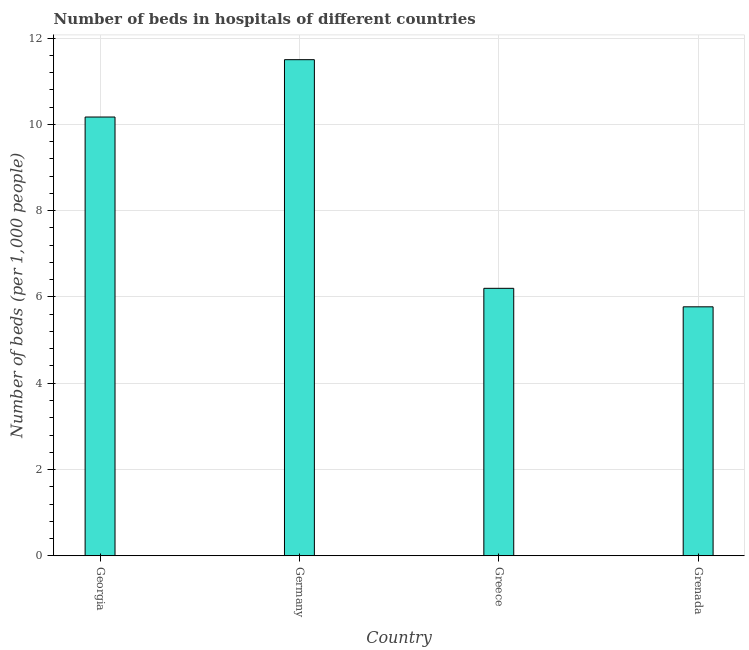Does the graph contain any zero values?
Provide a short and direct response. No. What is the title of the graph?
Offer a terse response. Number of beds in hospitals of different countries. What is the label or title of the X-axis?
Offer a terse response. Country. What is the label or title of the Y-axis?
Your answer should be compact. Number of beds (per 1,0 people). What is the number of hospital beds in Germany?
Your response must be concise. 11.5. Across all countries, what is the maximum number of hospital beds?
Provide a succinct answer. 11.5. Across all countries, what is the minimum number of hospital beds?
Give a very brief answer. 5.77. In which country was the number of hospital beds maximum?
Your answer should be compact. Germany. In which country was the number of hospital beds minimum?
Make the answer very short. Grenada. What is the sum of the number of hospital beds?
Provide a short and direct response. 33.64. What is the difference between the number of hospital beds in Georgia and Greece?
Offer a very short reply. 3.97. What is the average number of hospital beds per country?
Your answer should be compact. 8.41. What is the median number of hospital beds?
Your response must be concise. 8.19. What is the ratio of the number of hospital beds in Georgia to that in Germany?
Give a very brief answer. 0.88. What is the difference between the highest and the second highest number of hospital beds?
Offer a very short reply. 1.33. Is the sum of the number of hospital beds in Georgia and Greece greater than the maximum number of hospital beds across all countries?
Ensure brevity in your answer.  Yes. What is the difference between the highest and the lowest number of hospital beds?
Keep it short and to the point. 5.73. Are all the bars in the graph horizontal?
Offer a terse response. No. What is the difference between two consecutive major ticks on the Y-axis?
Your answer should be compact. 2. Are the values on the major ticks of Y-axis written in scientific E-notation?
Provide a succinct answer. No. What is the Number of beds (per 1,000 people) in Georgia?
Provide a short and direct response. 10.17. What is the Number of beds (per 1,000 people) in Greece?
Your answer should be very brief. 6.2. What is the Number of beds (per 1,000 people) of Grenada?
Keep it short and to the point. 5.77. What is the difference between the Number of beds (per 1,000 people) in Georgia and Germany?
Keep it short and to the point. -1.33. What is the difference between the Number of beds (per 1,000 people) in Georgia and Greece?
Your response must be concise. 3.97. What is the difference between the Number of beds (per 1,000 people) in Georgia and Grenada?
Offer a very short reply. 4.4. What is the difference between the Number of beds (per 1,000 people) in Germany and Grenada?
Offer a terse response. 5.73. What is the difference between the Number of beds (per 1,000 people) in Greece and Grenada?
Your answer should be compact. 0.43. What is the ratio of the Number of beds (per 1,000 people) in Georgia to that in Germany?
Your answer should be compact. 0.88. What is the ratio of the Number of beds (per 1,000 people) in Georgia to that in Greece?
Offer a terse response. 1.64. What is the ratio of the Number of beds (per 1,000 people) in Georgia to that in Grenada?
Provide a succinct answer. 1.76. What is the ratio of the Number of beds (per 1,000 people) in Germany to that in Greece?
Keep it short and to the point. 1.85. What is the ratio of the Number of beds (per 1,000 people) in Germany to that in Grenada?
Your response must be concise. 1.99. What is the ratio of the Number of beds (per 1,000 people) in Greece to that in Grenada?
Your answer should be very brief. 1.07. 